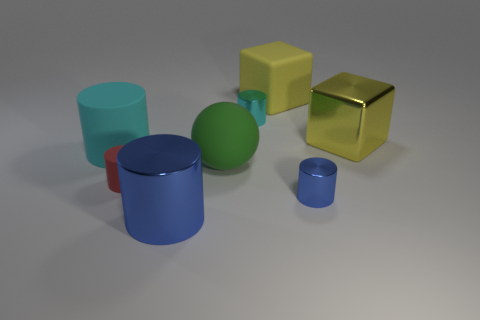Subtract all cyan metallic cylinders. How many cylinders are left? 4 Subtract all gray cubes. How many cyan cylinders are left? 2 Add 1 large yellow objects. How many objects exist? 9 Subtract all cyan cylinders. How many cylinders are left? 3 Subtract 3 cylinders. How many cylinders are left? 2 Subtract all balls. How many objects are left? 7 Subtract all cyan cylinders. Subtract all cyan blocks. How many cylinders are left? 3 Subtract all matte cylinders. Subtract all big red spheres. How many objects are left? 6 Add 6 big green rubber things. How many big green rubber things are left? 7 Add 5 red metallic balls. How many red metallic balls exist? 5 